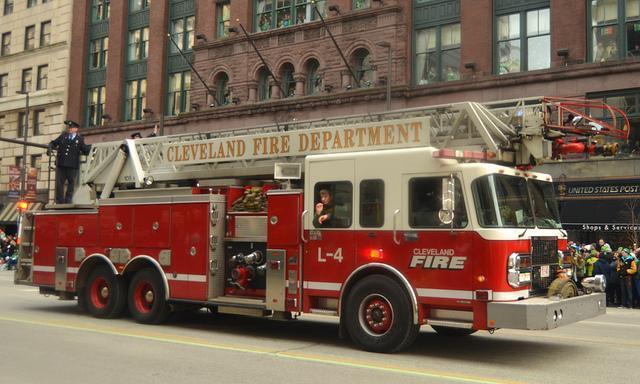How many people can be seen?
Give a very brief answer. 1. How many cars are in the left lane?
Give a very brief answer. 0. 